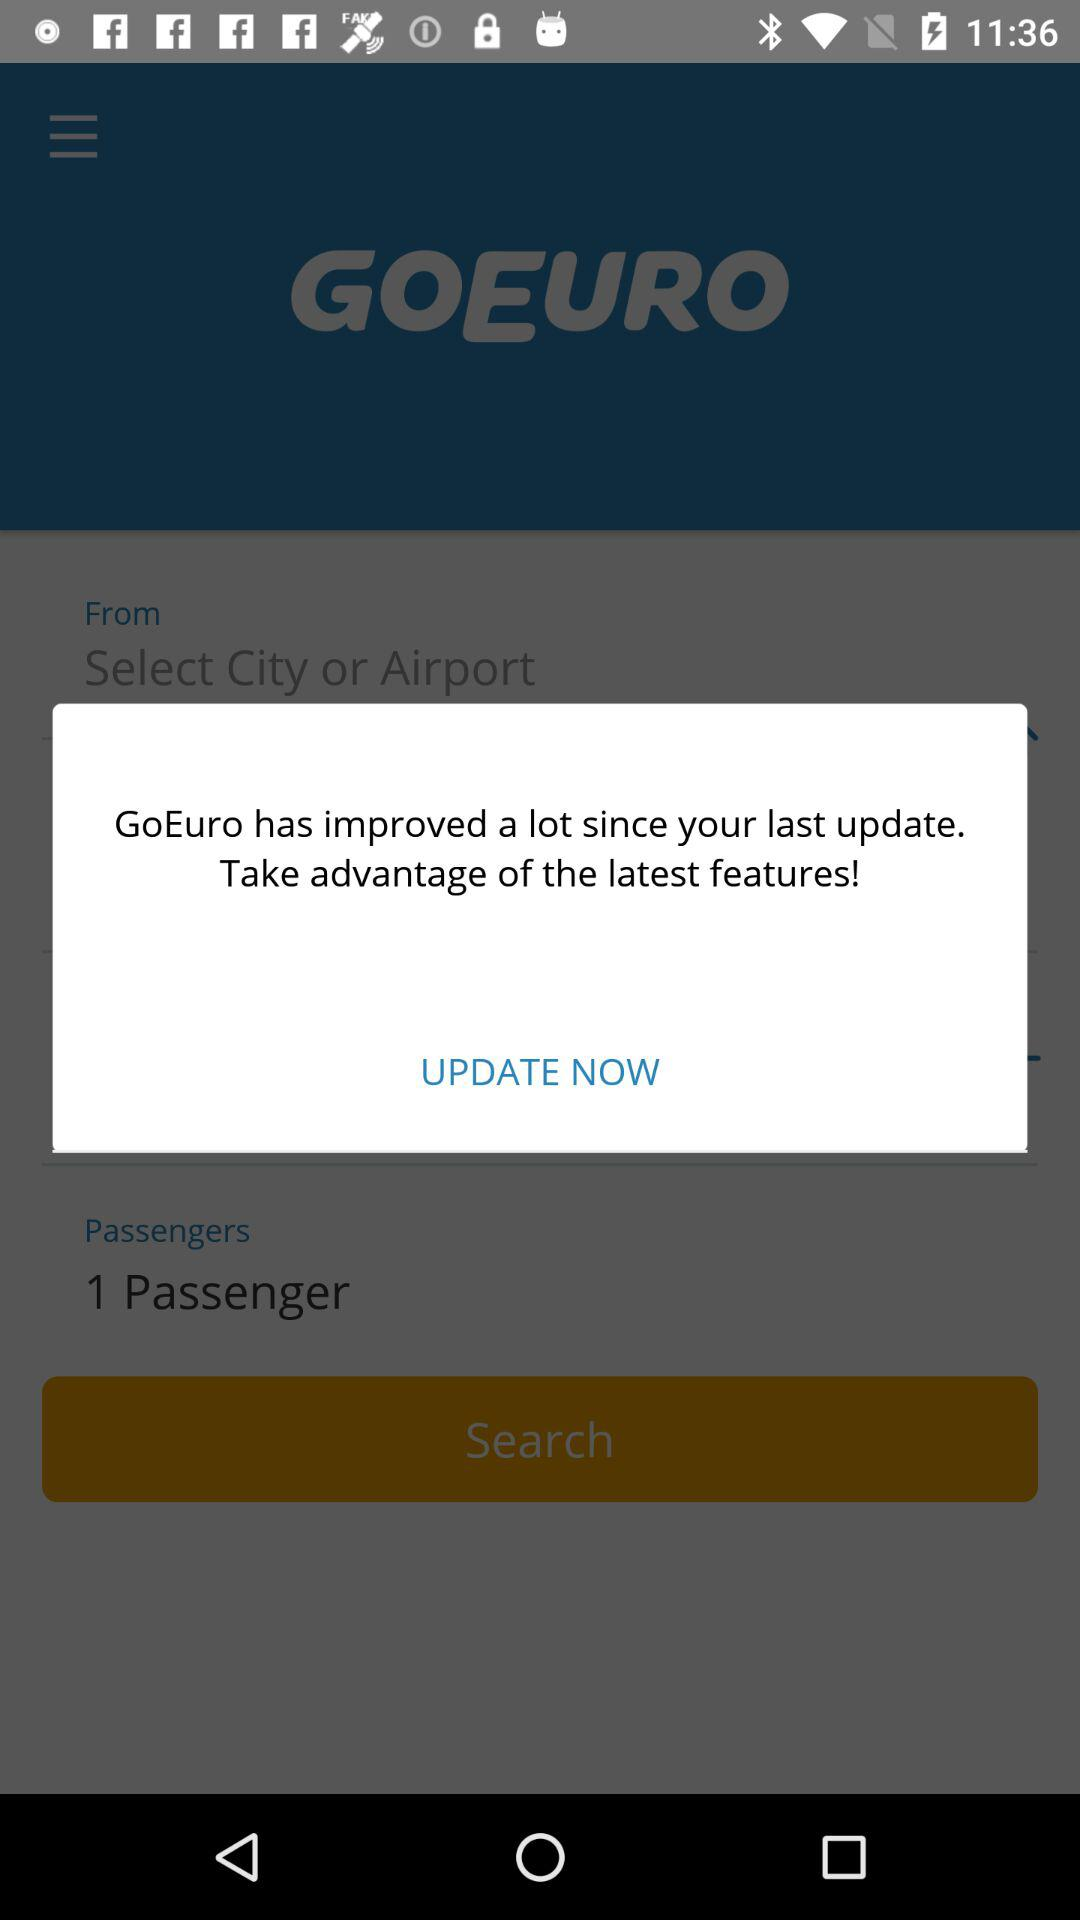What is the name of the application? The name of the application is "GoEuro". 